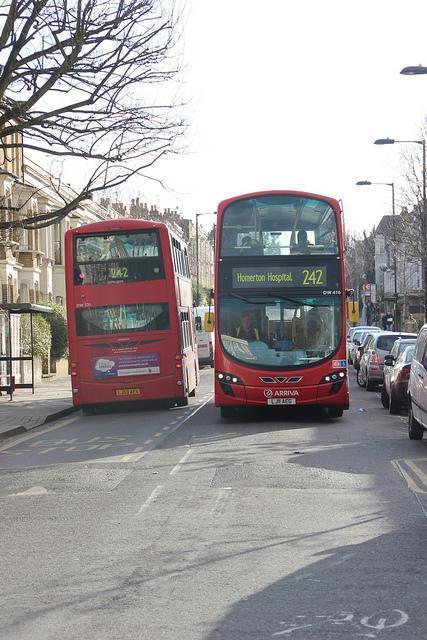How many buses can you see?
Give a very brief answer. 2. How many bottles are pictured?
Give a very brief answer. 0. 